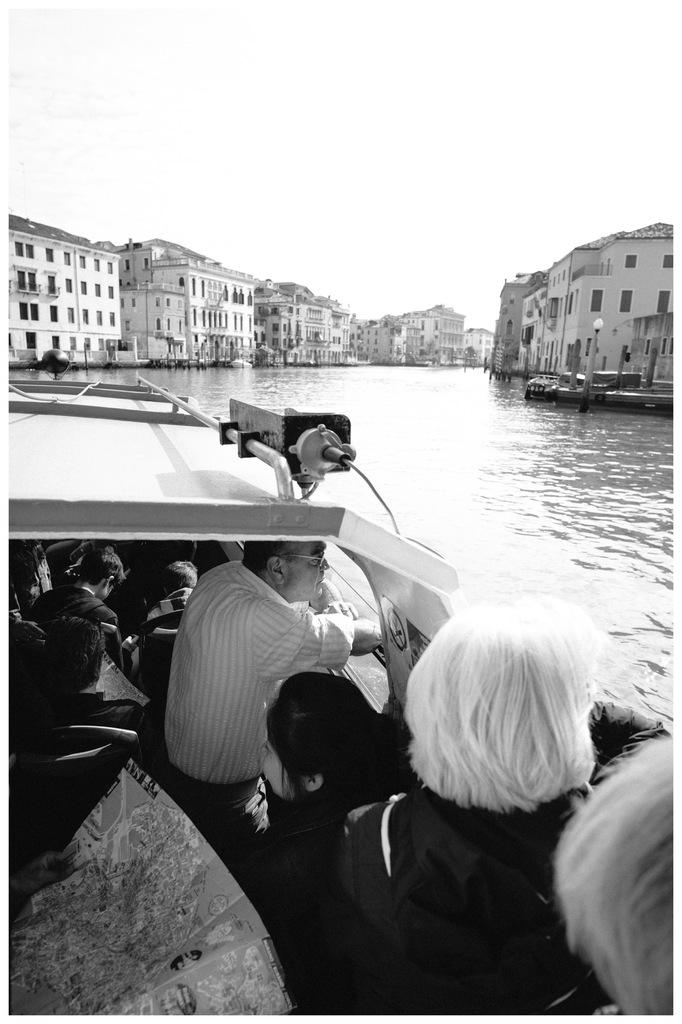What is the color scheme of the image? The image is black and white. What are the people in the image doing? The persons are sitting in the seats of a boat. Where is the boat located? The boat is on the water. What other objects can be seen in the image? There are street poles, street lights, and buildings visible in the image. What part of the natural environment is visible in the image? The sky is visible in the image. What type of cushion is used to support the roots of the street poles in the image? There is no cushion or mention of roots in the image; it features a boat on the water with people sitting in it, street poles, street lights, buildings, and a visible sky. 